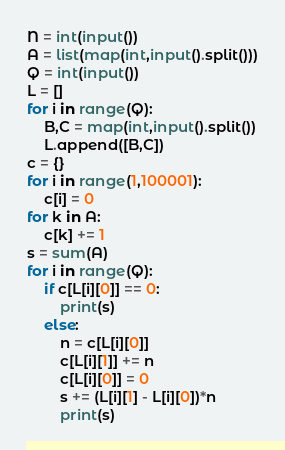<code> <loc_0><loc_0><loc_500><loc_500><_Python_>N = int(input())
A = list(map(int,input().split()))
Q = int(input())
L = []
for i in range(Q):
    B,C = map(int,input().split())
    L.append([B,C])
c = {}
for i in range(1,100001):
    c[i] = 0
for k in A:
    c[k] += 1
s = sum(A)
for i in range(Q):
    if c[L[i][0]] == 0:
        print(s)
    else:
        n = c[L[i][0]]
        c[L[i][1]] += n
        c[L[i][0]] = 0
        s += (L[i][1] - L[i][0])*n
        print(s)</code> 